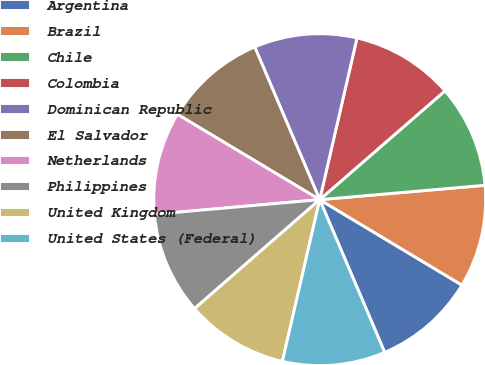<chart> <loc_0><loc_0><loc_500><loc_500><pie_chart><fcel>Argentina<fcel>Brazil<fcel>Chile<fcel>Colombia<fcel>Dominican Republic<fcel>El Salvador<fcel>Netherlands<fcel>Philippines<fcel>United Kingdom<fcel>United States (Federal)<nl><fcel>9.99%<fcel>9.99%<fcel>10.0%<fcel>10.01%<fcel>10.01%<fcel>10.0%<fcel>10.0%<fcel>10.0%<fcel>9.99%<fcel>10.01%<nl></chart> 